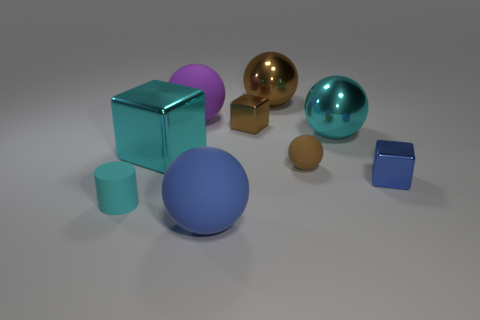How many objects are either blue balls or metallic things behind the cyan cube?
Make the answer very short. 4. What is the color of the other small cube that is the same material as the small blue cube?
Offer a terse response. Brown. How many objects are tiny blue cubes or cyan rubber things?
Make the answer very short. 2. The block that is the same size as the cyan ball is what color?
Your response must be concise. Cyan. How many objects are either matte objects to the right of the matte cylinder or large blocks?
Make the answer very short. 4. How many other objects are there of the same size as the purple object?
Give a very brief answer. 4. What is the size of the metallic object that is left of the large purple matte sphere?
Keep it short and to the point. Large. What shape is the purple object that is made of the same material as the tiny brown sphere?
Your response must be concise. Sphere. Is there anything else that is the same color as the cylinder?
Offer a very short reply. Yes. What is the color of the rubber thing that is left of the big shiny object in front of the cyan ball?
Your answer should be compact. Cyan. 